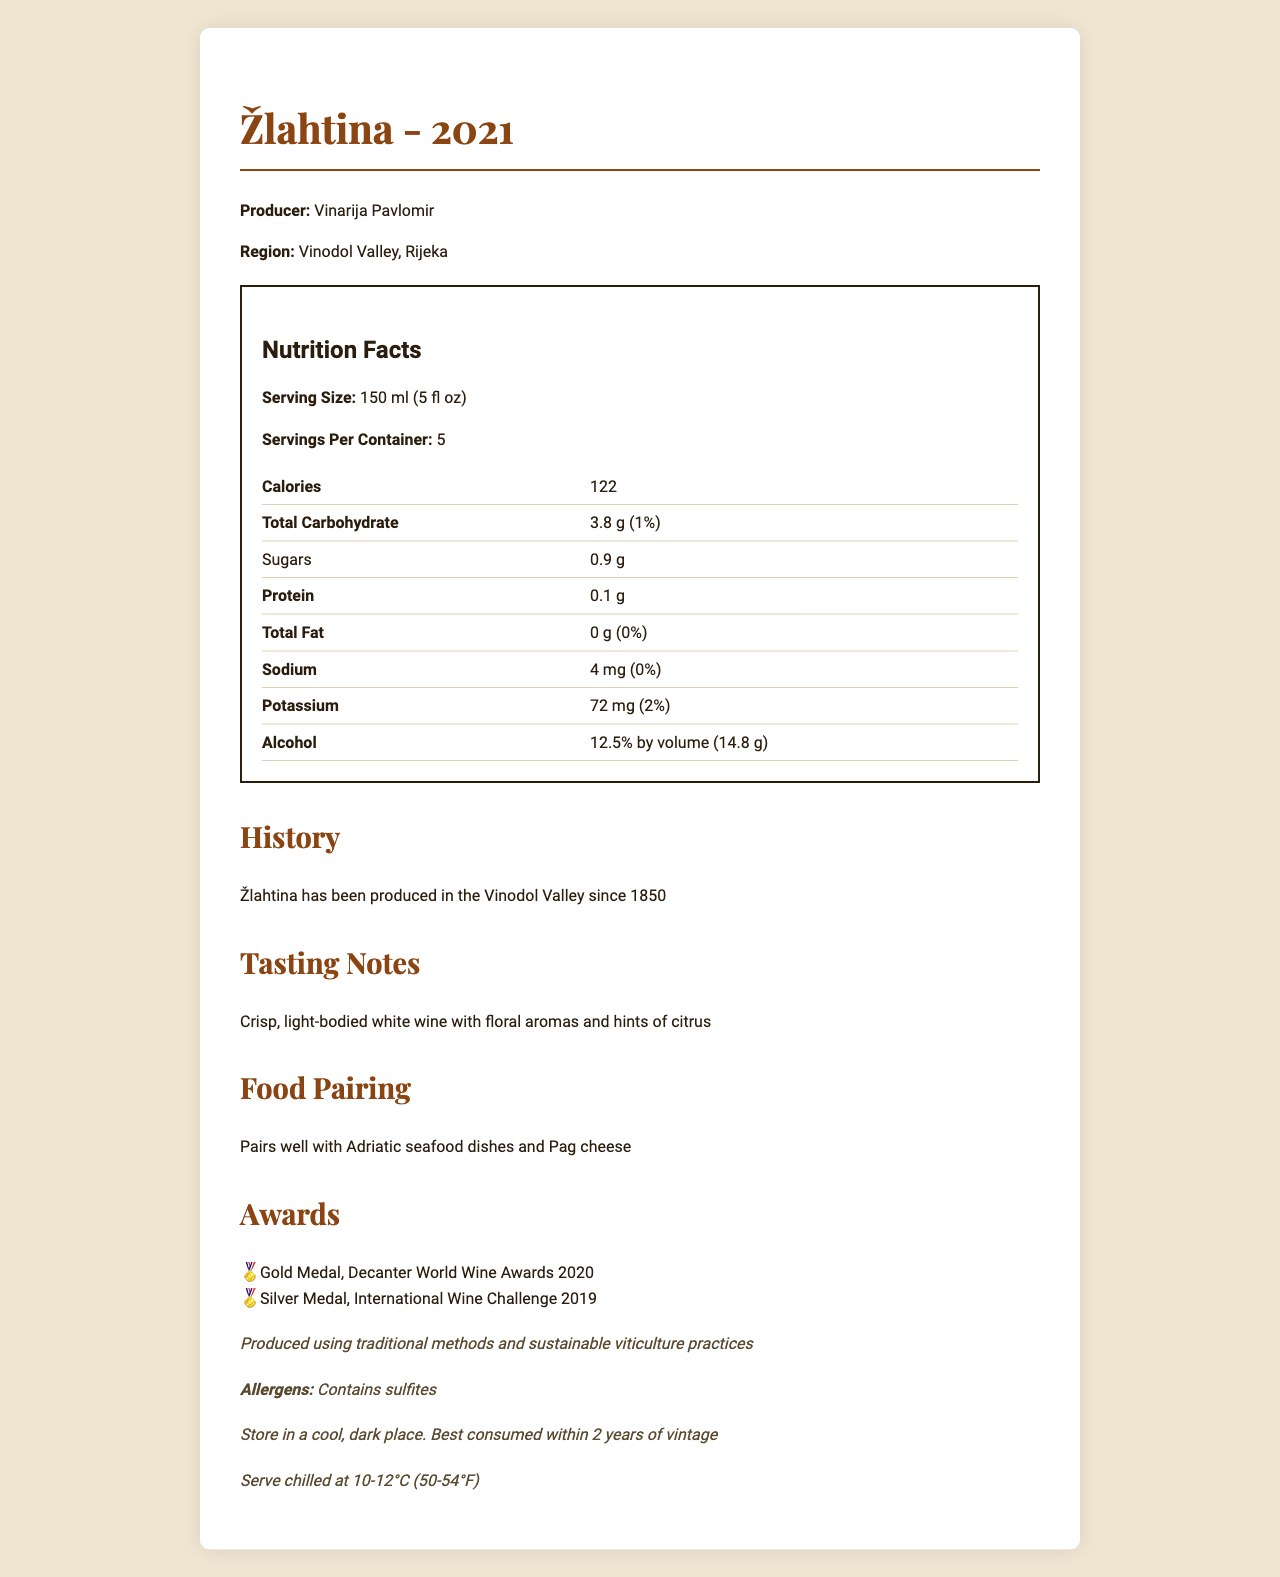what is the serving size of Žlahtina? The serving size is explicitly stated in the nutrition facts section as 150 ml (5 fl oz).
Answer: 150 ml (5 fl oz) who is the producer of Žlahtina? The producer information is located at the top of the document under the product name and vintage.
Answer: Vinarija Pavlomir what is the alcohol content by volume in Žlahtina? The alcohol content by volume is indicated in the nutrition facts section as 12.5%.
Answer: 12.5% by volume what is the potassium daily value percentage in Žlahtina? The daily value percentage for potassium is listed in the nutrition facts table and is specified as 2%.
Answer: 2% how many grams of sugars are in one serving of Žlahtina? The amount of sugars per serving is listed in the nutrition facts table as 0.9 g.
Answer: 0.9 g for how many years has Žlahtina been produced in the Vinodol Valley? A. since 1800 B. since 1850 C. since 1880 The history section states that Žlahtina has been produced in the Vinodol Valley since 1850.
Answer: B. since 1850 which of the following awards did Žlahtina win? i. Bronze Medal, Decanter World Wine Awards 2020 ii. Gold Medal, Decanter World Wine Awards 2020 iii. Silver Medal, International Wine Challenge 2019 Choose all that apply. The awards section lists the Gold Medal, Decanter World Wine Awards 2020, and the Silver Medal, International Wine Challenge 2019.
Answer: ii and iii is the wine suitable for people with a sulfite allergy? The document mentions that Žlahtina contains sulfites, making it unsuitable for people with a sulfite allergy.
Answer: No what are the tasting notes for Žlahtina? The tasting notes section describes the characteristics of the wine as crisp, light-bodied with floral aromas and hints of citrus.
Answer: Crisp, light-bodied white wine with floral aromas and hints of citrus what should be the serving temperature for Žlahtina? The serving temperature is indicated near the bottom of the document, suggesting to serve chilled at 10-12°C (50-54°F).
Answer: Serve chilled at 10-12°C (50-54°F) which region is Žlahtina produced in? The region is mentioned under the producer and product name section at the top of the document.
Answer: Vinodol Valley, Rijeka what is the main food pairing suggested for Žlahtina? The food pairing section suggests that Žlahtina pairs well with Adriatic seafood dishes and Pag cheese.
Answer: Adriatic seafood dishes and Pag cheese summarize the main points of the document. The document provides information on the Žlahtina wine, including its producer, region, vintage, nutritional facts, tasting notes, food pairings, awards, and storage instructions. It highlights the wine's history and sustainability practices as well.
Answer: Žlahtina, a crisp, light-bodied white wine produced by Vinarija Pavlomir in the Vinodol Valley, Rijeka, since 1850, has won multiple awards and pairs well with Adriatic seafood and Pag cheese. Key nutritional facts include its 12.5% alcohol content by volume, 0.9 g of sugars, and it contains sulfites. It should be served chilled at 10-12°C and stored in a cool, dark place. what is the price of Żlahtina? The document does not provide any information regarding the price of Żlahtina.
Answer: Not enough information 